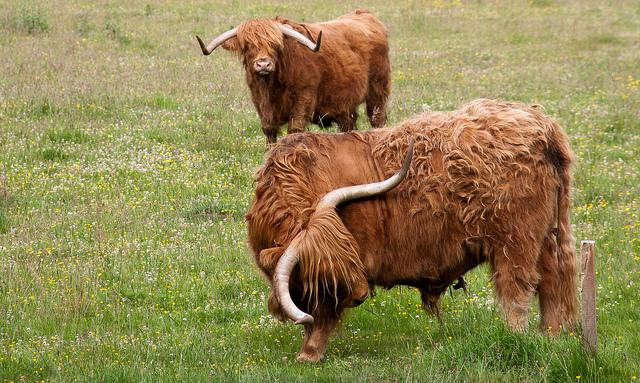What animal is this?
Be succinct. Buffalo. How many are they?
Write a very short answer. 2. Would it be dangerous to anger this animal?
Answer briefly. Yes. Can you milk these cows?
Concise answer only. No. Might this animal have a problem with visibility?
Give a very brief answer. Yes. How many horns are there?
Short answer required. 4. 